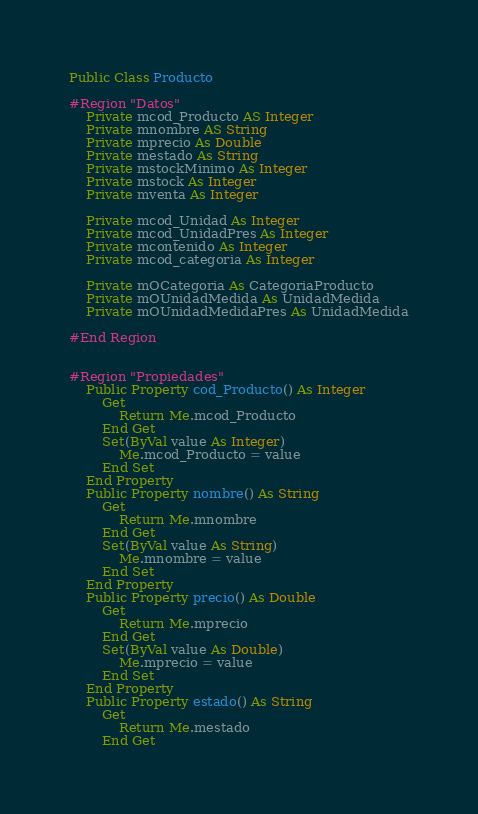<code> <loc_0><loc_0><loc_500><loc_500><_VisualBasic_>Public Class Producto

#Region "Datos"
	Private mcod_Producto AS Integer
	Private mnombre AS String
    Private mprecio As Double
    Private mestado As String
    Private mstockMinimo As Integer
    Private mstock As Integer
    Private mventa As Integer

    Private mcod_Unidad As Integer
    Private mcod_UnidadPres As Integer
    Private mcontenido As Integer
    Private mcod_categoria As Integer

    Private mOCategoria As CategoriaProducto
    Private mOUnidadMedida As UnidadMedida
    Private mOUnidadMedidaPres As UnidadMedida

#End Region


#Region "Propiedades"
    Public Property cod_Producto() As Integer
        Get
            Return Me.mcod_Producto
        End Get
        Set(ByVal value As Integer)
            Me.mcod_Producto = value
        End Set
    End Property
    Public Property nombre() As String
        Get
            Return Me.mnombre
        End Get
        Set(ByVal value As String)
            Me.mnombre = value
        End Set
    End Property
    Public Property precio() As Double
        Get
            Return Me.mprecio
        End Get
        Set(ByVal value As Double)
            Me.mprecio = value
        End Set
    End Property
    Public Property estado() As String
        Get
            Return Me.mestado
        End Get</code> 